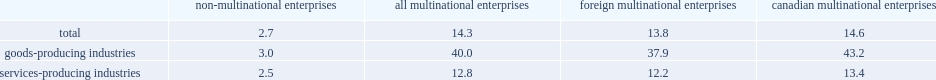How many times did an mne employ as many people per establishment as a non-mne? 14.3. How many times did an mne employ as many people per establishment as a non-mne? 2.7. 